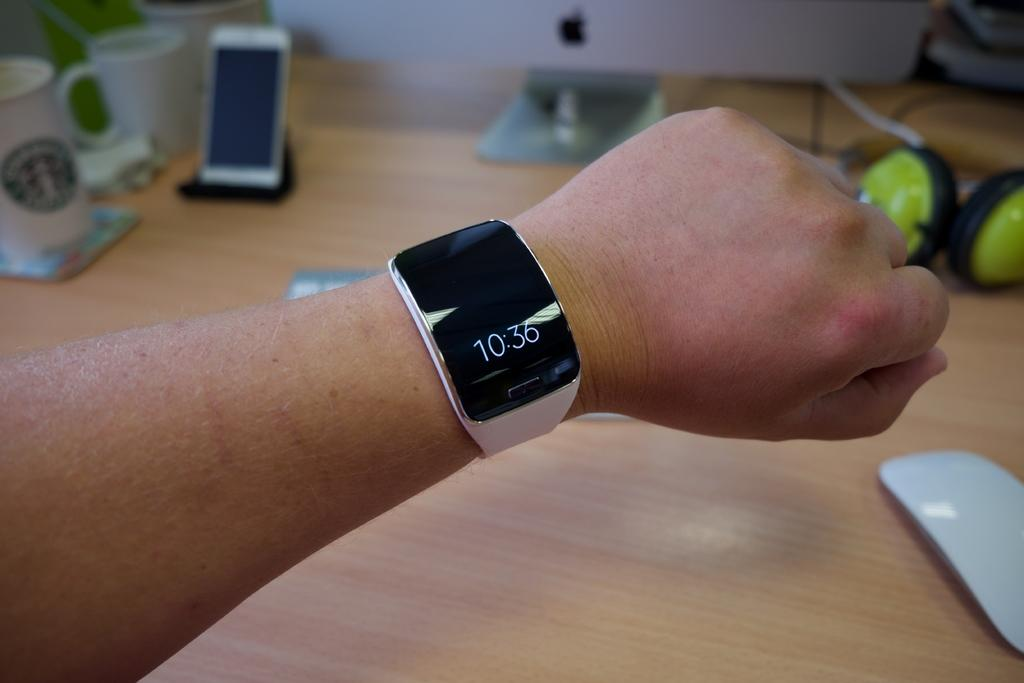<image>
Present a compact description of the photo's key features. A man with a watch on his wrist with displaying 10:36 